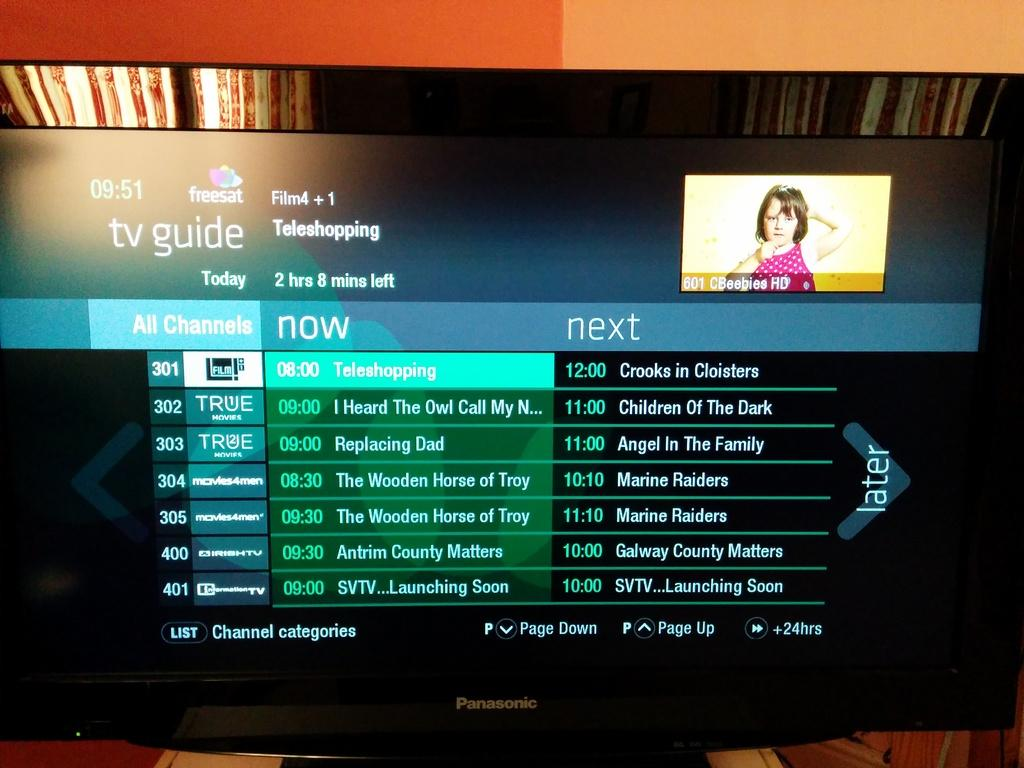<image>
Render a clear and concise summary of the photo. The tv guide is listing shows on True tv and Irish tv. 